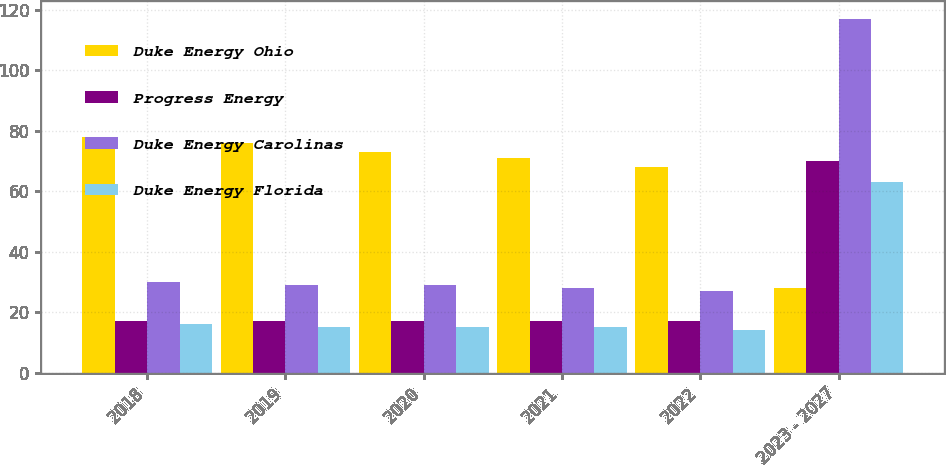Convert chart. <chart><loc_0><loc_0><loc_500><loc_500><stacked_bar_chart><ecel><fcel>2018<fcel>2019<fcel>2020<fcel>2021<fcel>2022<fcel>2023 - 2027<nl><fcel>Duke Energy Ohio<fcel>78<fcel>76<fcel>73<fcel>71<fcel>68<fcel>28<nl><fcel>Progress Energy<fcel>17<fcel>17<fcel>17<fcel>17<fcel>17<fcel>70<nl><fcel>Duke Energy Carolinas<fcel>30<fcel>29<fcel>29<fcel>28<fcel>27<fcel>117<nl><fcel>Duke Energy Florida<fcel>16<fcel>15<fcel>15<fcel>15<fcel>14<fcel>63<nl></chart> 